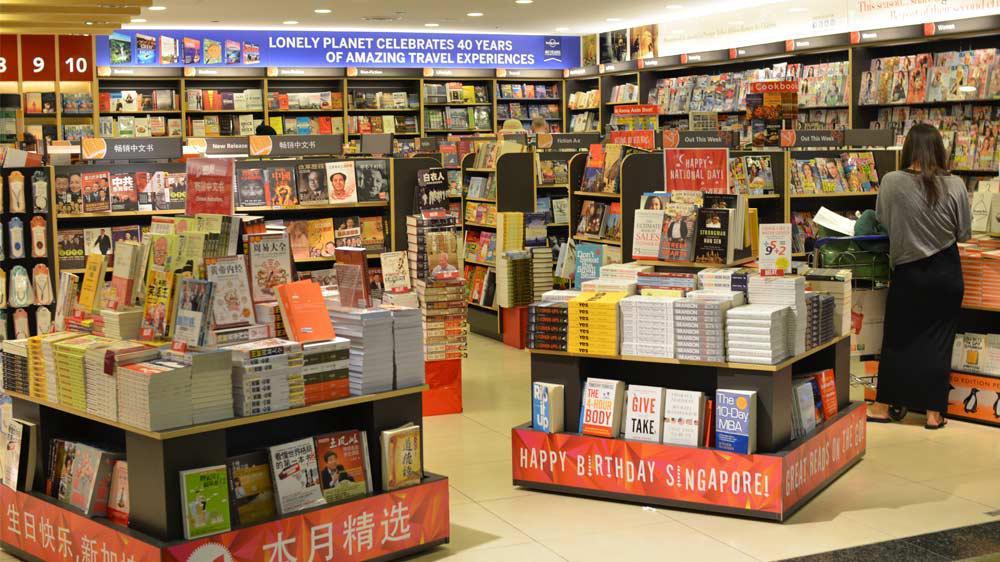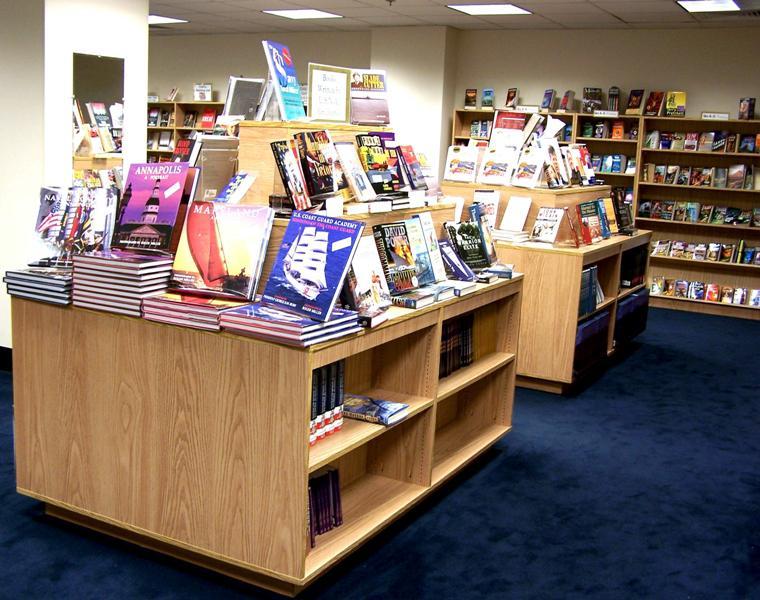The first image is the image on the left, the second image is the image on the right. Assess this claim about the two images: "There are no more than 3 people in the image on the left.". Correct or not? Answer yes or no. Yes. 